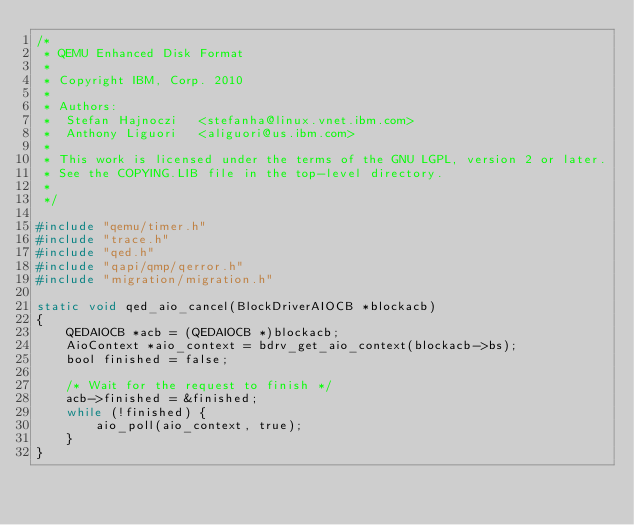<code> <loc_0><loc_0><loc_500><loc_500><_C_>/*
 * QEMU Enhanced Disk Format
 *
 * Copyright IBM, Corp. 2010
 *
 * Authors:
 *  Stefan Hajnoczi   <stefanha@linux.vnet.ibm.com>
 *  Anthony Liguori   <aliguori@us.ibm.com>
 *
 * This work is licensed under the terms of the GNU LGPL, version 2 or later.
 * See the COPYING.LIB file in the top-level directory.
 *
 */

#include "qemu/timer.h"
#include "trace.h"
#include "qed.h"
#include "qapi/qmp/qerror.h"
#include "migration/migration.h"

static void qed_aio_cancel(BlockDriverAIOCB *blockacb)
{
    QEDAIOCB *acb = (QEDAIOCB *)blockacb;
    AioContext *aio_context = bdrv_get_aio_context(blockacb->bs);
    bool finished = false;

    /* Wait for the request to finish */
    acb->finished = &finished;
    while (!finished) {
        aio_poll(aio_context, true);
    }
}
</code> 